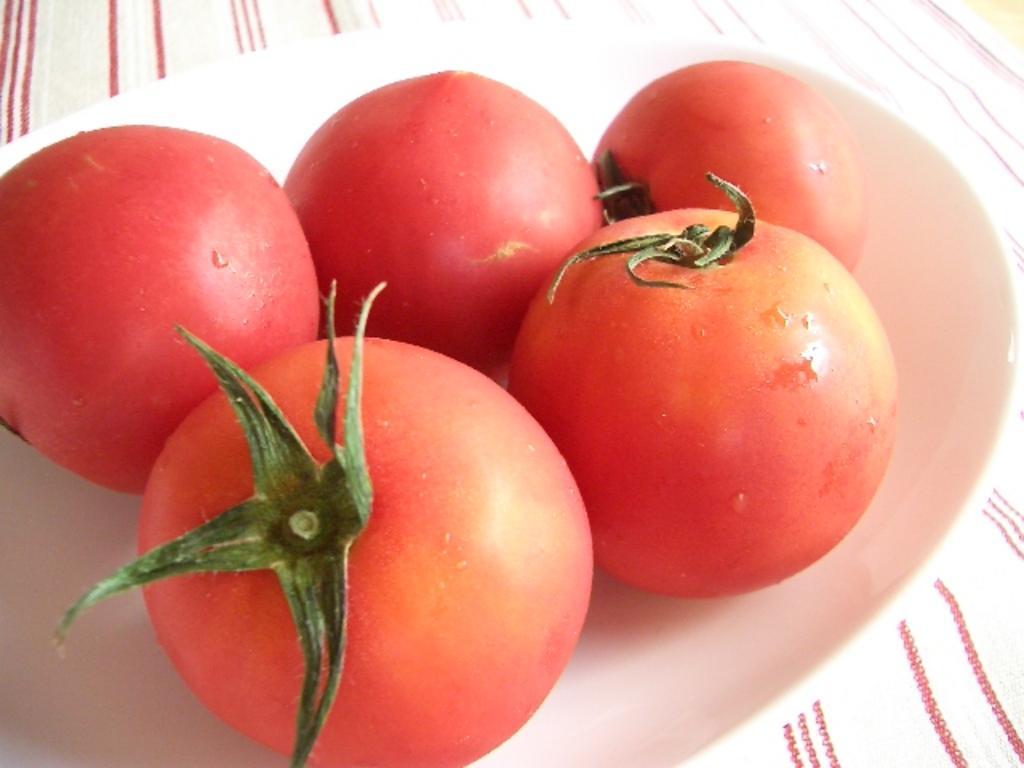Can you describe this image briefly? In the picture I can see a plate in which there are some tomatoes. 